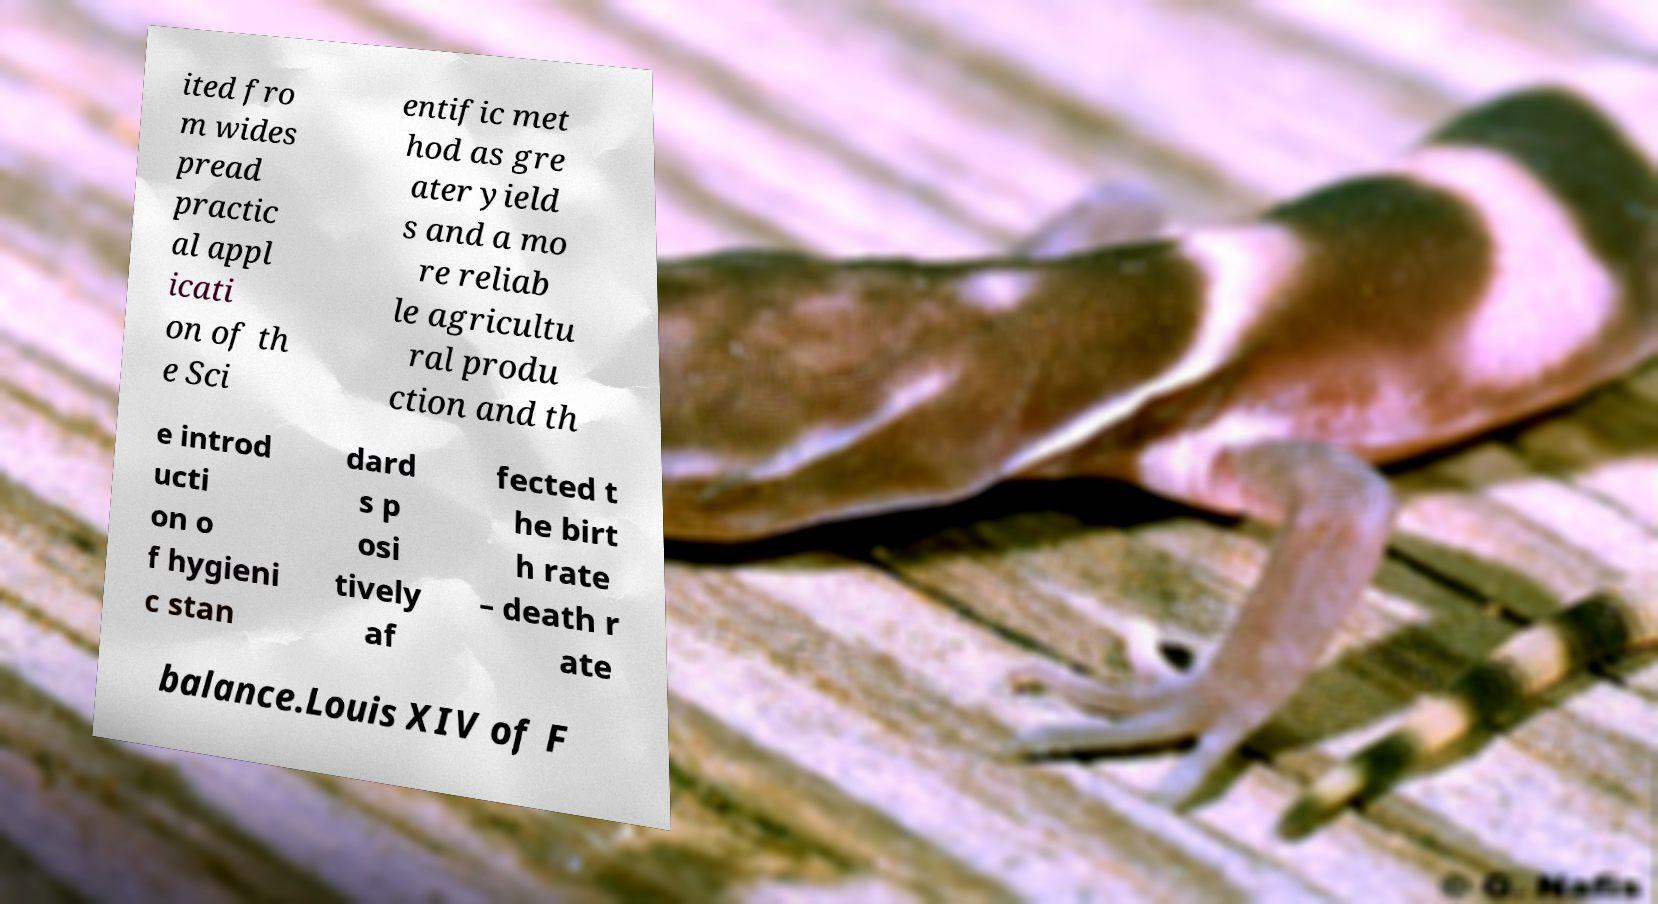Can you accurately transcribe the text from the provided image for me? ited fro m wides pread practic al appl icati on of th e Sci entific met hod as gre ater yield s and a mo re reliab le agricultu ral produ ction and th e introd ucti on o f hygieni c stan dard s p osi tively af fected t he birt h rate – death r ate balance.Louis XIV of F 